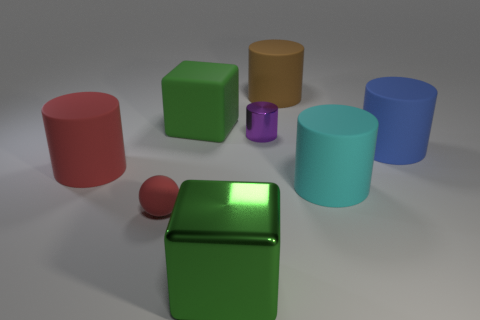There is a big cyan cylinder that is on the right side of the green cube that is behind the small red thing; are there any big cyan rubber cylinders right of it?
Your answer should be compact. No. What is the cube in front of the small cylinder made of?
Provide a succinct answer. Metal. Do the green rubber cube and the metal cylinder have the same size?
Your response must be concise. No. There is a big matte cylinder that is behind the large cyan matte object and on the right side of the brown cylinder; what is its color?
Your answer should be compact. Blue. The brown thing that is made of the same material as the red cylinder is what shape?
Provide a succinct answer. Cylinder. How many large matte things are behind the large cyan matte cylinder and in front of the brown object?
Your answer should be very brief. 3. Are there any matte balls to the right of the small cylinder?
Your answer should be very brief. No. Does the green object that is behind the small red matte ball have the same shape as the large object in front of the tiny rubber ball?
Give a very brief answer. Yes. How many objects are either big green rubber blocks or matte things behind the red sphere?
Provide a short and direct response. 5. What number of other things are the same shape as the big green metal object?
Offer a very short reply. 1. 